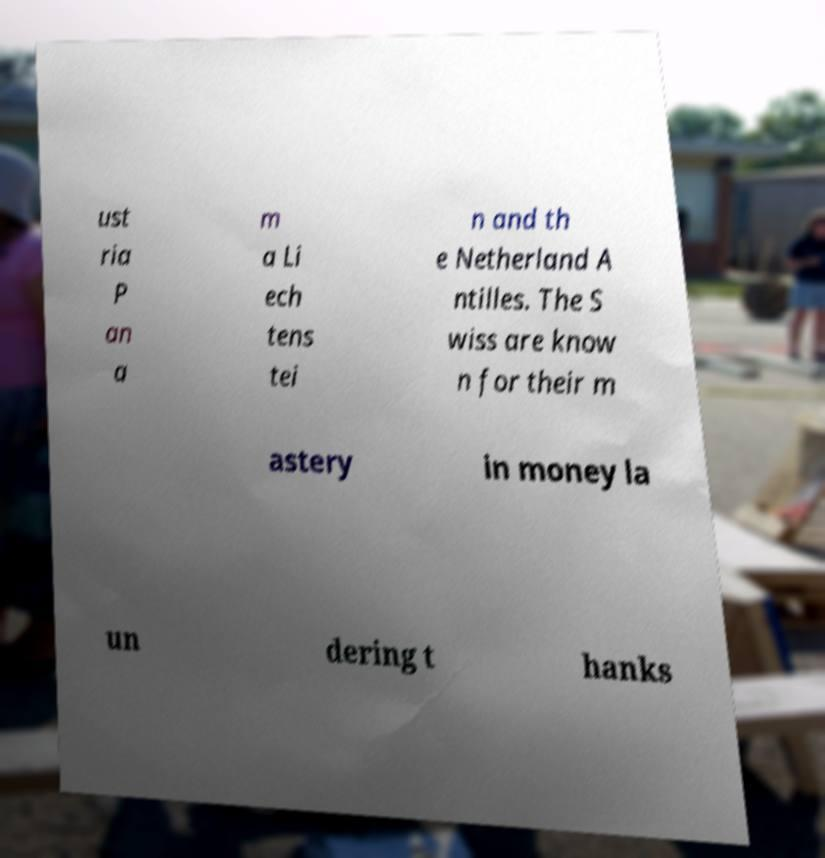Can you read and provide the text displayed in the image?This photo seems to have some interesting text. Can you extract and type it out for me? ust ria P an a m a Li ech tens tei n and th e Netherland A ntilles. The S wiss are know n for their m astery in money la un dering t hanks 